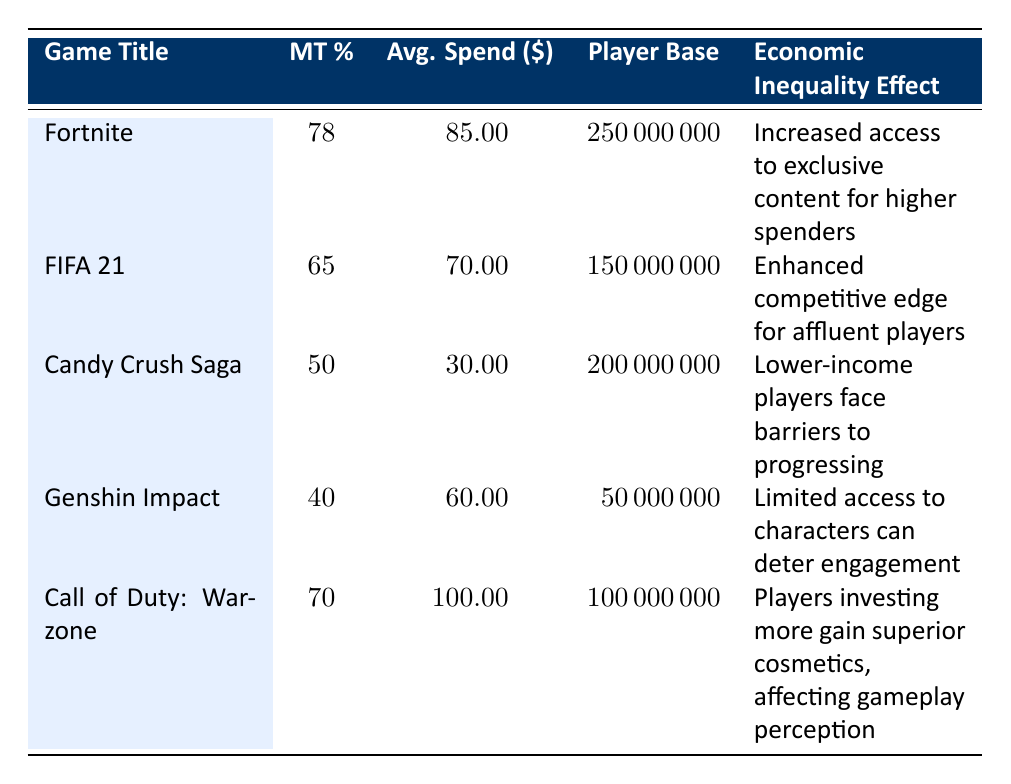What percentage of players in Fortnite spend money on microtransactions? The table states that 78% of players in Fortnite engage in microtransactions.
Answer: 78% Which game has the highest average spend per player? By comparing the average spend values, Call of Duty: Warzone has the highest at $100.00.
Answer: $100.00 What is the average spend per player for Candy Crush Saga? The table lists the average spend for Candy Crush Saga as $30.00.
Answer: $30.00 How many players are in FIFA 21? The number of players in FIFA 21, according to the table, is 150,000,000.
Answer: 150,000,000 Which game has a microtransaction percentage lower than 50%? The only game with a microtransaction percentage lower than 50% is Genshin Impact, at 40%.
Answer: Genshin Impact What is the economic inequality effect reported for Candy Crush Saga? The effect listed for Candy Crush Saga is that lower-income players face barriers to progressing.
Answer: Lower-income players face barriers to progressing If we average the microtransaction percentages of all games, what is the result? The percentages are 78, 65, 50, 40, and 70. Their sum is 403, and dividing by the number of games (5) gives an average of 80.60.
Answer: 80.60 What age group is most prevalent among players of Fortnite? According to the demographics for Fortnite, the most prevalent age group is 16-24.
Answer: 16-24 Is there a game where female players constitute more than 50% of the demographic? Yes, in Candy Crush Saga, female players make up 70% of the demographic, which is greater than 50%.
Answer: Yes What effect do high spenders in Call of Duty: Warzone experience? The table indicates that high spenders in Call of Duty: Warzone gain superior cosmetics, affecting gameplay perception.
Answer: Superior cosmetics, affecting gameplay perception How does the economic inequality effect of FIFA 21 differ from that of Genshin Impact? FIFA 21 enhances competitive edges for affluent players, while Genshin Impact limits access to characters, which can deter engagement.
Answer: FIFA 21 enhances competitive edges; Genshin Impact limits access 